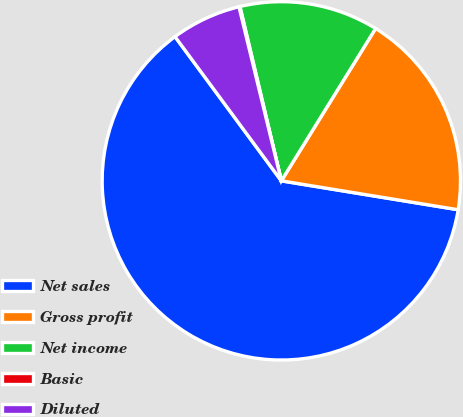Convert chart to OTSL. <chart><loc_0><loc_0><loc_500><loc_500><pie_chart><fcel>Net sales<fcel>Gross profit<fcel>Net income<fcel>Basic<fcel>Diluted<nl><fcel>62.31%<fcel>18.76%<fcel>12.53%<fcel>0.09%<fcel>6.31%<nl></chart> 